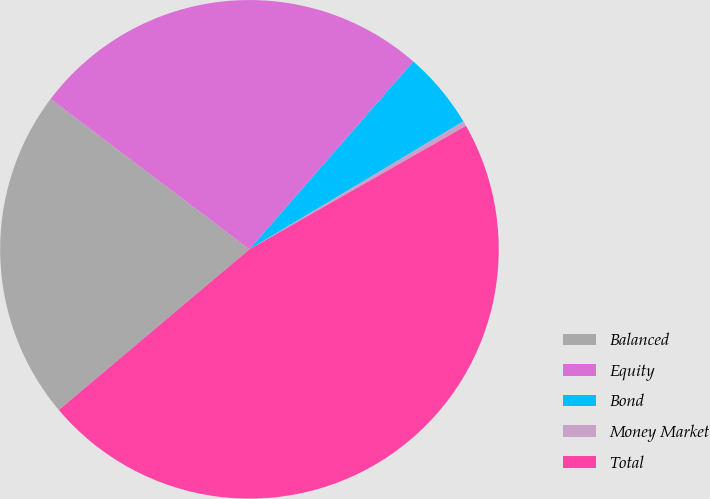<chart> <loc_0><loc_0><loc_500><loc_500><pie_chart><fcel>Balanced<fcel>Equity<fcel>Bond<fcel>Money Market<fcel>Total<nl><fcel>21.45%<fcel>26.12%<fcel>5.0%<fcel>0.33%<fcel>47.1%<nl></chart> 